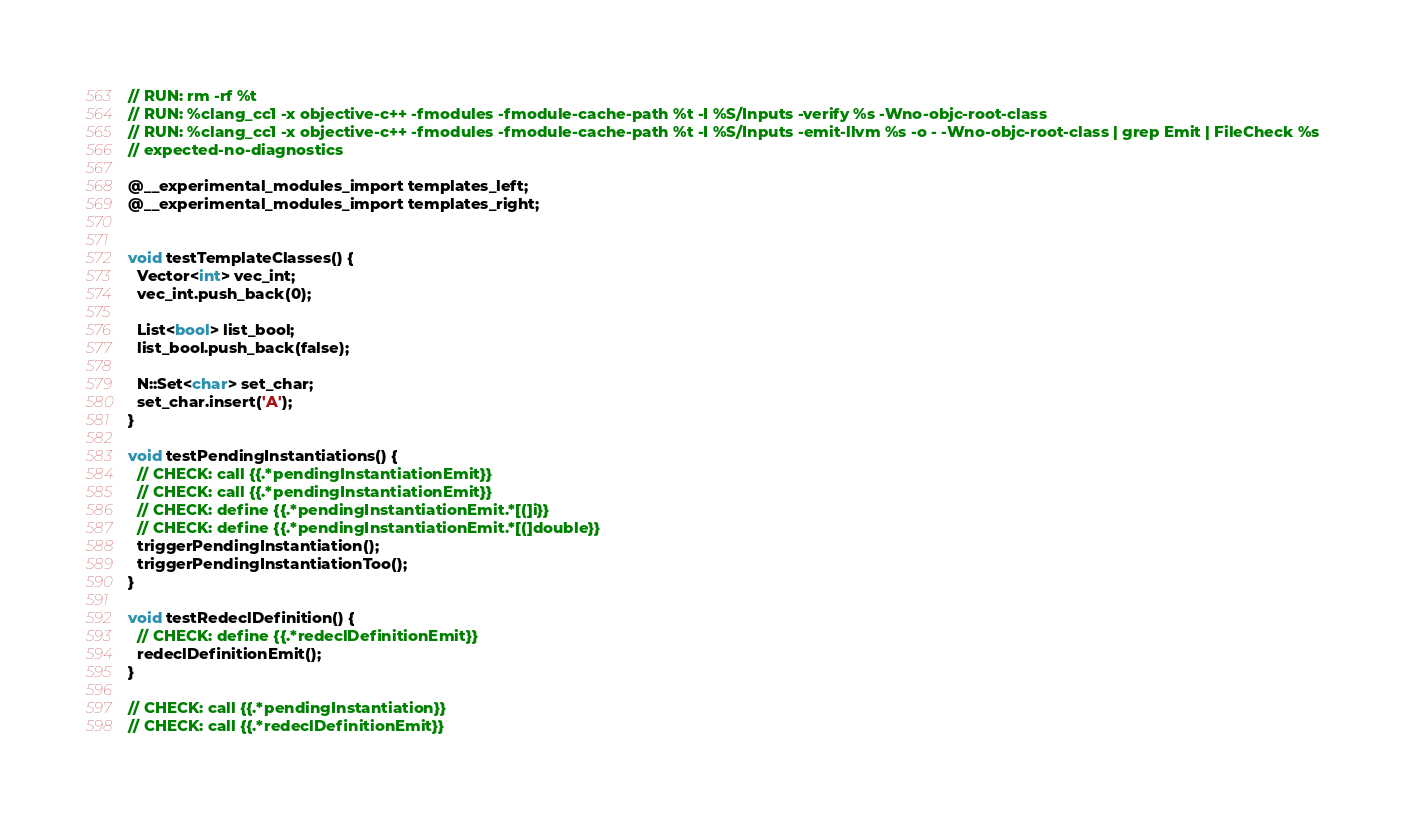Convert code to text. <code><loc_0><loc_0><loc_500><loc_500><_ObjectiveC_>// RUN: rm -rf %t
// RUN: %clang_cc1 -x objective-c++ -fmodules -fmodule-cache-path %t -I %S/Inputs -verify %s -Wno-objc-root-class
// RUN: %clang_cc1 -x objective-c++ -fmodules -fmodule-cache-path %t -I %S/Inputs -emit-llvm %s -o - -Wno-objc-root-class | grep Emit | FileCheck %s
// expected-no-diagnostics

@__experimental_modules_import templates_left;
@__experimental_modules_import templates_right;


void testTemplateClasses() {
  Vector<int> vec_int;
  vec_int.push_back(0);

  List<bool> list_bool;
  list_bool.push_back(false);

  N::Set<char> set_char;
  set_char.insert('A');
}

void testPendingInstantiations() {
  // CHECK: call {{.*pendingInstantiationEmit}}
  // CHECK: call {{.*pendingInstantiationEmit}}
  // CHECK: define {{.*pendingInstantiationEmit.*[(]i}}
  // CHECK: define {{.*pendingInstantiationEmit.*[(]double}}
  triggerPendingInstantiation();
  triggerPendingInstantiationToo();
}

void testRedeclDefinition() {
  // CHECK: define {{.*redeclDefinitionEmit}}
  redeclDefinitionEmit();
}

// CHECK: call {{.*pendingInstantiation}}
// CHECK: call {{.*redeclDefinitionEmit}}
</code> 